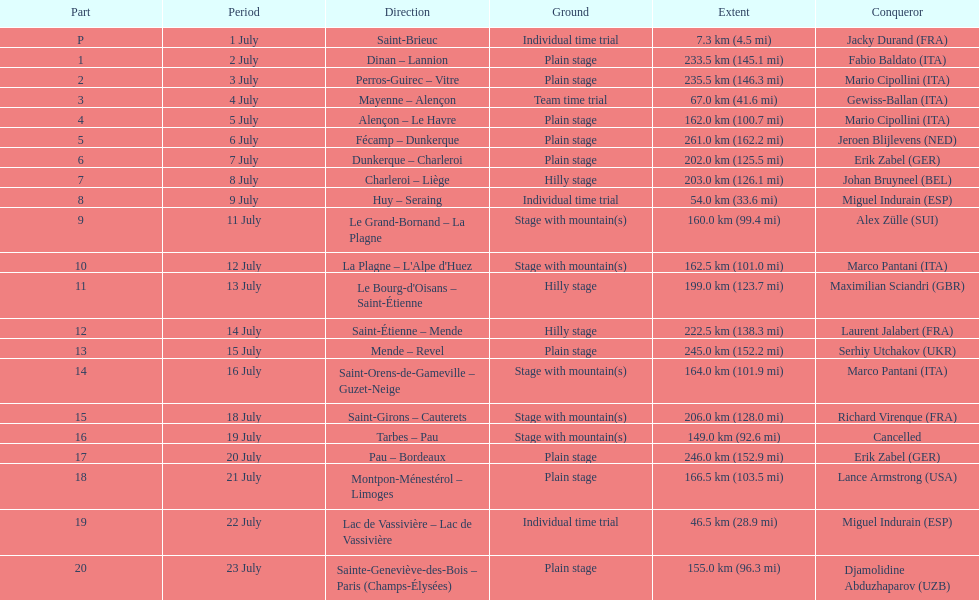What was the number of stages in the 1995 tour de france that were 200 km or longer? 9. 